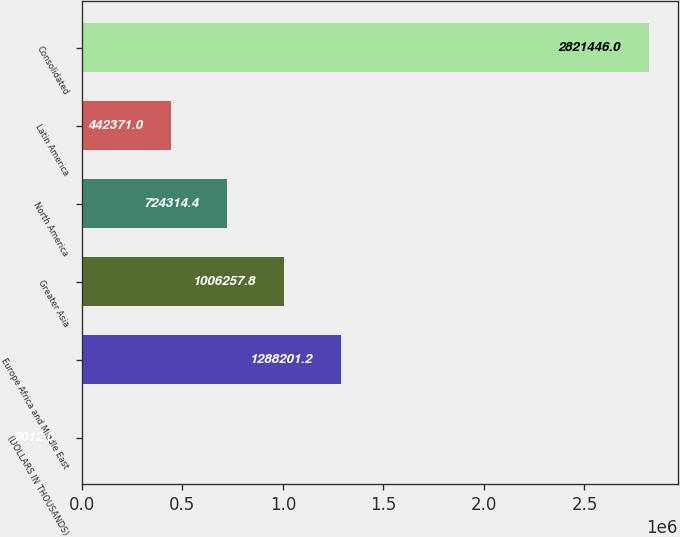<chart> <loc_0><loc_0><loc_500><loc_500><bar_chart><fcel>(DOLLARS IN THOUSANDS)<fcel>Europe Africa and Middle East<fcel>Greater Asia<fcel>North America<fcel>Latin America<fcel>Consolidated<nl><fcel>2012<fcel>1.2882e+06<fcel>1.00626e+06<fcel>724314<fcel>442371<fcel>2.82145e+06<nl></chart> 